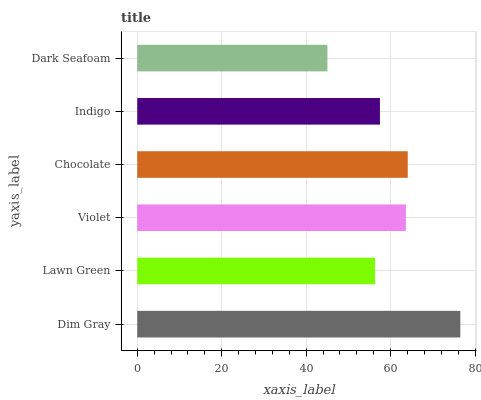Is Dark Seafoam the minimum?
Answer yes or no. Yes. Is Dim Gray the maximum?
Answer yes or no. Yes. Is Lawn Green the minimum?
Answer yes or no. No. Is Lawn Green the maximum?
Answer yes or no. No. Is Dim Gray greater than Lawn Green?
Answer yes or no. Yes. Is Lawn Green less than Dim Gray?
Answer yes or no. Yes. Is Lawn Green greater than Dim Gray?
Answer yes or no. No. Is Dim Gray less than Lawn Green?
Answer yes or no. No. Is Violet the high median?
Answer yes or no. Yes. Is Indigo the low median?
Answer yes or no. Yes. Is Dark Seafoam the high median?
Answer yes or no. No. Is Dim Gray the low median?
Answer yes or no. No. 